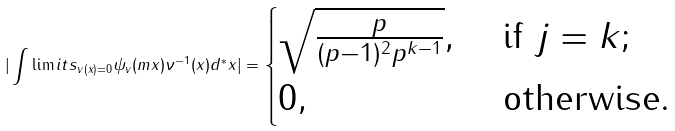Convert formula to latex. <formula><loc_0><loc_0><loc_500><loc_500>| \int \lim i t s _ { v ( x ) = 0 } \psi _ { v } ( m x ) \nu ^ { - 1 } ( x ) d ^ { * } x | = \begin{cases} \sqrt { \frac { p } { ( p - 1 ) ^ { 2 } p ^ { k - 1 } } } , & \text {\ if\ } j = k ; \\ 0 , & \text {\ otherwise.} \end{cases}</formula> 